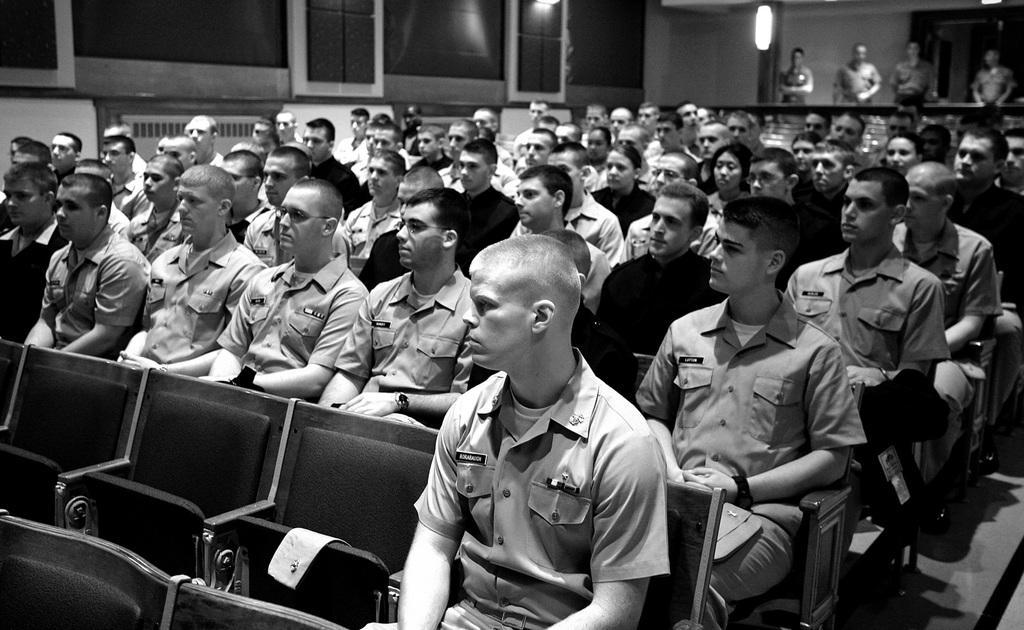Can you describe this image briefly? In this image I can see number of people where few are standing and rest all are sitting on chairs. I can also see most of them are wearing uniforms and here I can see few empty chairs. I can also see few lights and I can see this image is black and white in colour. 